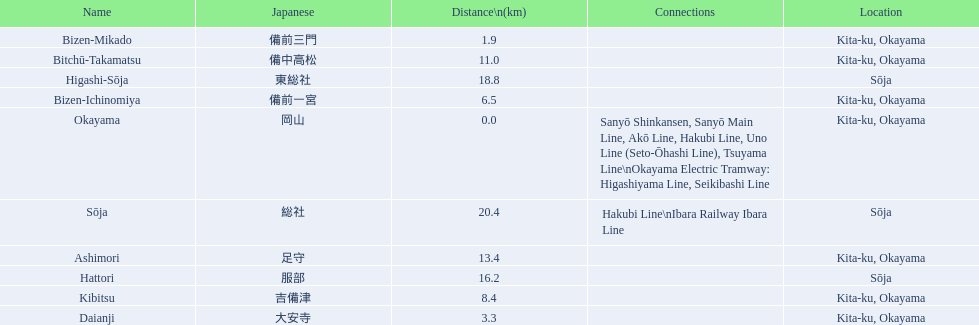What are all of the train names? Okayama, Bizen-Mikado, Daianji, Bizen-Ichinomiya, Kibitsu, Bitchū-Takamatsu, Ashimori, Hattori, Higashi-Sōja, Sōja. What is the distance for each? 0.0, 1.9, 3.3, 6.5, 8.4, 11.0, 13.4, 16.2, 18.8, 20.4. And which train's distance is between 1 and 2 km? Bizen-Mikado. 